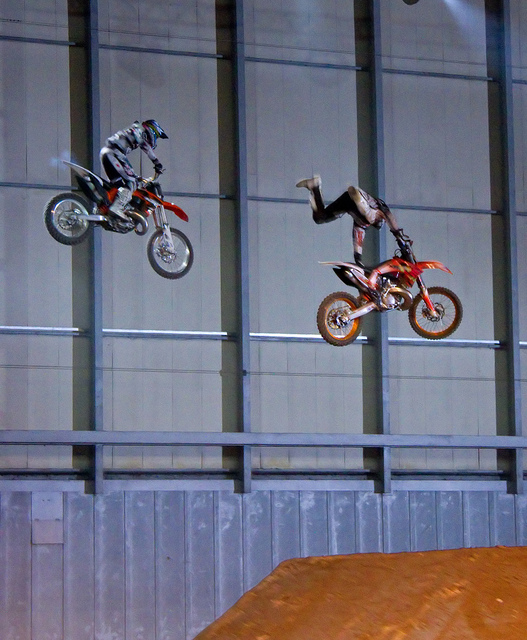Can you describe the safety gear the riders are wearing? Both riders are equipped with essential safety gear for motocross which includes helmets, goggles, gloves, boots, and body armor designed to protect against falls and flying debris. How important is this gear? This gear is crucial as it significantly reduces the risk of serious injury during falls or when performing stunts. Motocross is a high-impact sport, and the right safety gear is an essential part of rider protection. 